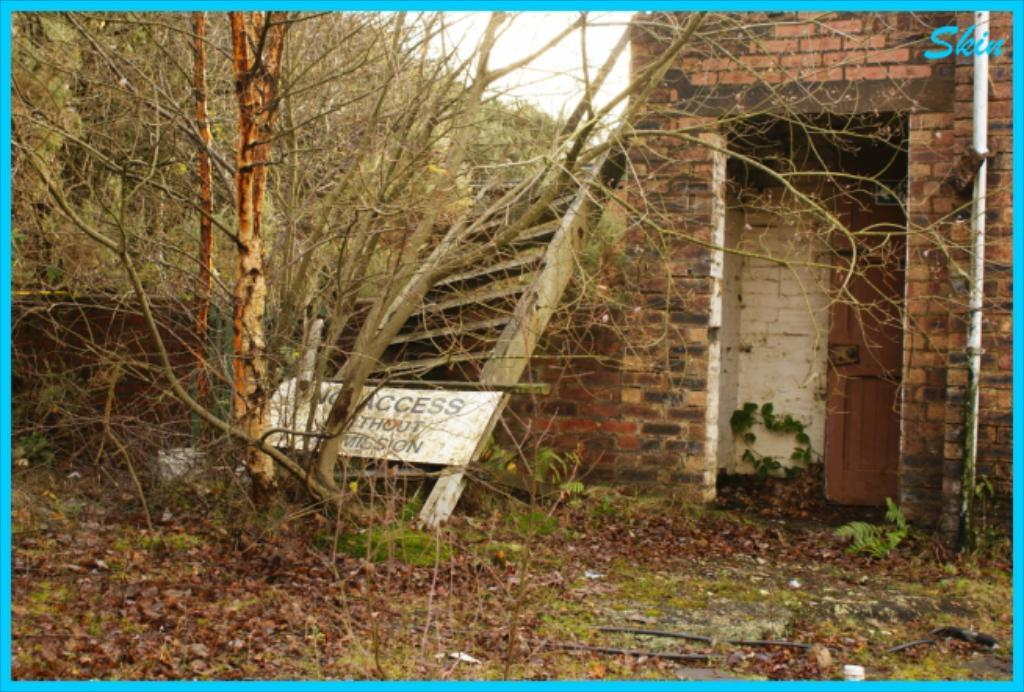<image>
Offer a succinct explanation of the picture presented. A building with a sign warning no access without permission. 